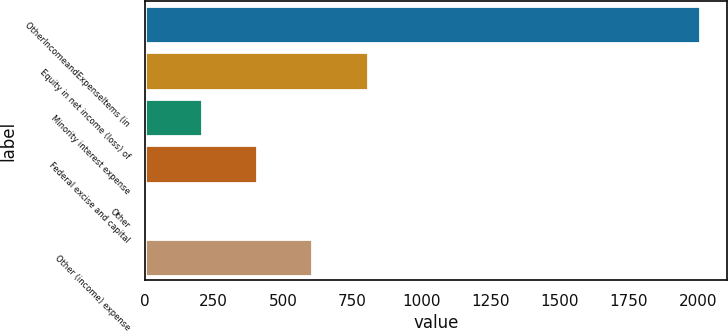<chart> <loc_0><loc_0><loc_500><loc_500><bar_chart><fcel>OtherIncomeandExpenseItems (in<fcel>Equity in net income (loss) of<fcel>Minority interest expense<fcel>Federal excise and capital<fcel>Other<fcel>Other (income) expense<nl><fcel>2006<fcel>806.6<fcel>206.9<fcel>406.8<fcel>7<fcel>606.7<nl></chart> 